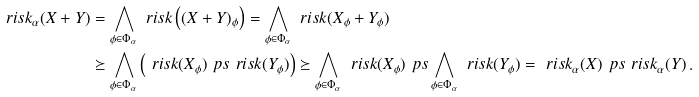<formula> <loc_0><loc_0><loc_500><loc_500>\ r i s k _ { \alpha } ( X + Y ) & = \bigwedge _ { \phi \in \Phi _ { \alpha } } \ r i s k \left ( ( X + Y ) _ { \phi } \right ) = \bigwedge _ { \phi \in \Phi _ { \alpha } } \ r i s k ( X _ { \phi } + Y _ { \phi } ) \\ & \succeq \bigwedge _ { \phi \in \Phi _ { \alpha } } \left ( \ r i s k ( X _ { \phi } ) \ p s \ r i s k ( Y _ { \phi } ) \right ) \succeq \bigwedge _ { \phi \in \Phi _ { \alpha } } \ r i s k ( X _ { \phi } ) \ p s \bigwedge _ { \phi \in \Phi _ { \alpha } } \ r i s k ( Y _ { \phi } ) = \ r i s k _ { \alpha } ( X ) \ p s \ r i s k _ { \alpha } ( Y ) \, .</formula> 